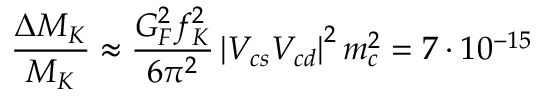Convert formula to latex. <formula><loc_0><loc_0><loc_500><loc_500>\frac { \Delta M _ { K } } { M _ { K } } \approx \frac { G _ { F } ^ { 2 } f _ { K } ^ { 2 } } { 6 \pi ^ { 2 } } \left | V _ { c s } V _ { c d } \right | ^ { 2 } m _ { c } ^ { 2 } = 7 \cdot 1 0 ^ { - 1 5 }</formula> 